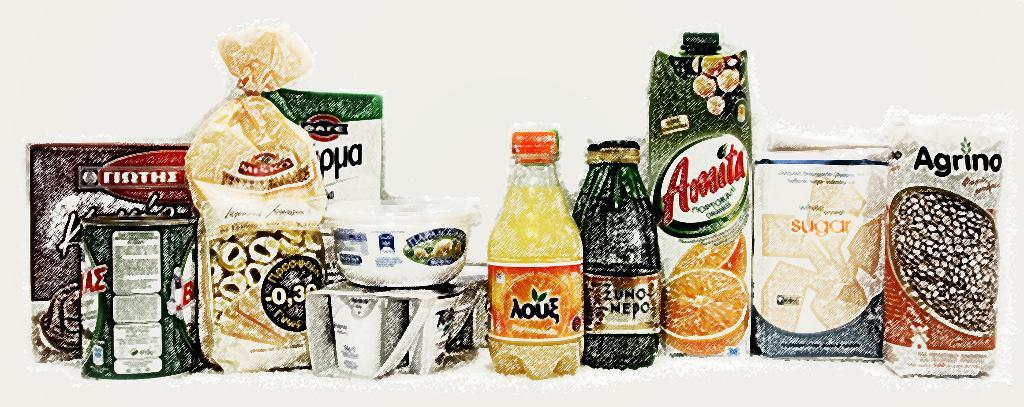What company made the product in the bag on the far right?
Offer a terse response. Agrino. 